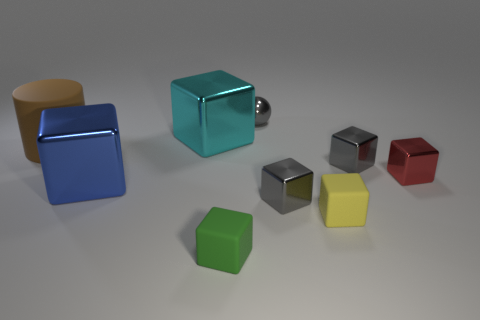Subtract all gray metallic cubes. How many cubes are left? 5 Subtract all gray cubes. How many cubes are left? 5 Subtract all brown blocks. Subtract all gray balls. How many blocks are left? 7 Add 1 large red rubber spheres. How many objects exist? 10 Subtract all blocks. How many objects are left? 2 Add 5 large cyan metallic things. How many large cyan metallic things are left? 6 Add 9 red metallic blocks. How many red metallic blocks exist? 10 Subtract 0 blue cylinders. How many objects are left? 9 Subtract all tiny red metallic cubes. Subtract all brown cylinders. How many objects are left? 7 